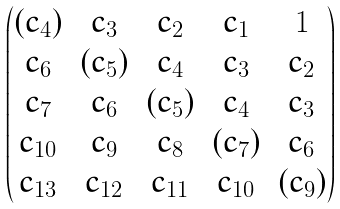<formula> <loc_0><loc_0><loc_500><loc_500>\begin{pmatrix} ( c _ { 4 } ) & c _ { 3 } & c _ { 2 } & c _ { 1 } & 1 \\ c _ { 6 } & ( c _ { 5 } ) & c _ { 4 } & c _ { 3 } & c _ { 2 } \\ c _ { 7 } & c _ { 6 } & ( c _ { 5 } ) & c _ { 4 } & c _ { 3 } \\ c _ { 1 0 } & c _ { 9 } & c _ { 8 } & ( c _ { 7 } ) & c _ { 6 } \\ c _ { 1 3 } & c _ { 1 2 } & c _ { 1 1 } & c _ { 1 0 } & ( c _ { 9 } ) \\ \end{pmatrix}</formula> 